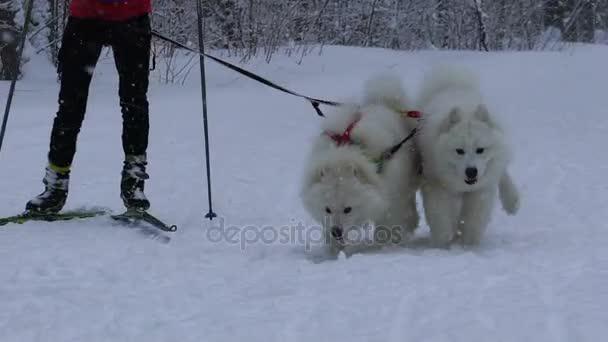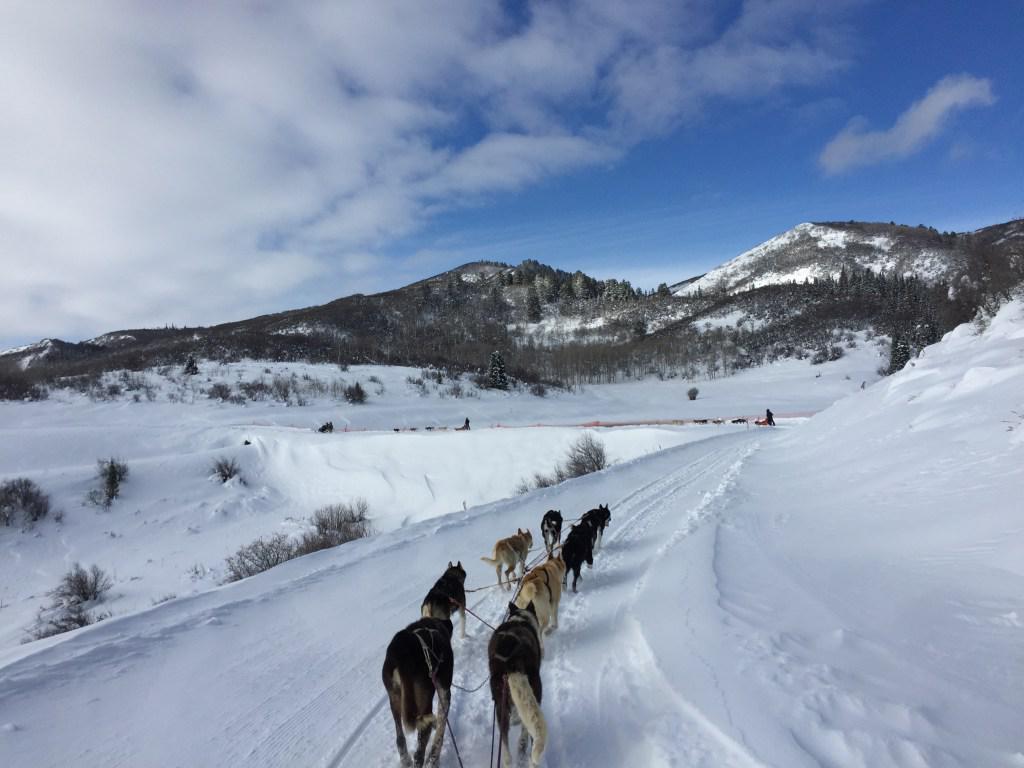The first image is the image on the left, the second image is the image on the right. Considering the images on both sides, is "One image shows a team of dogs heading away from the camera toward a background of mountains." valid? Answer yes or no. Yes. The first image is the image on the left, the second image is the image on the right. For the images displayed, is the sentence "In one of the images, at least one dog on a leash is anchored to the waist of a person on skis." factually correct? Answer yes or no. Yes. 